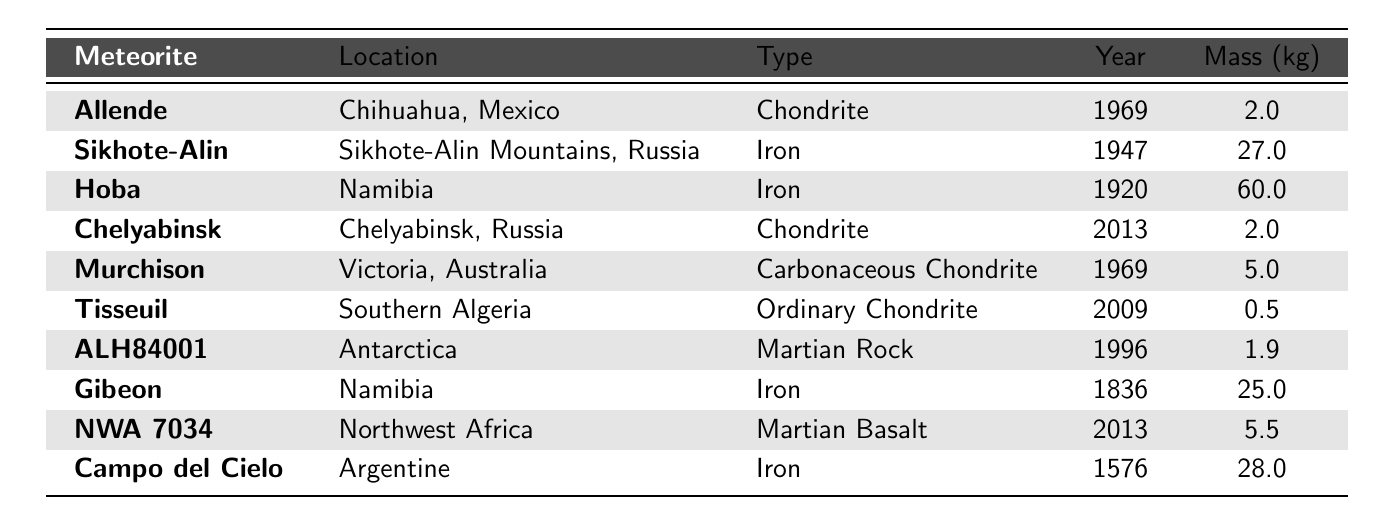What is the total mass of all exhibited meteorites? To find the total mass, we sum the masses listed in the table: 2.0 + 27.0 + 60.0 + 2.0 + 5.0 + 0.5 + 1.9 + 25.0 + 5.5 + 28.0 = 157.9 kg.
Answer: 157.9 kg Which meteorite was exhibited in the earliest year? Looking at the "Year" column, we see that "Campo del Cielo" was exhibited in 1576, which is the earliest year in the table.
Answer: Campo del Cielo How many iron meteorites are exhibited? By counting the entries in the "Type" column, we find that there are three iron meteorites: "Sikhote-Alin," "Hoba," and "Gibeon."
Answer: 4 What is the average mass of all exhibited meteorites? To calculate the average mass, we sum the masses (157.9 kg as discovered previously) and divide by the number of meteorites (10): 157.9 / 10 = 15.79 kg.
Answer: 15.79 kg Are there any meteorites that weigh less than 1 kg? Checking the "Mass" column, we find that "Tisseuil" has a mass of 0.5 kg, which is less than 1 kg.
Answer: Yes Which location has the largest meteorite by mass, and what is its mass? The meteorite "Hoba," located in Namibia, has the largest mass of 60.0 kg according to the "Mass" column.
Answer: Hoba, 60.0 kg How many meteorites were exhibited after the year 2000? From the "Year" column, we see that "Tisseuil," "ALH84001," "NWA 7034," and "Chelyabinsk" were exhibited after 2000. This gives us a total of 4 meteorites.
Answer: 4 Is there any meteorite from Antarctica? The table lists "ALH84001" and indicates that it is located in Antarctica.
Answer: Yes Which type of meteorite has the highest average mass? The average mass for each type is calculated: Iron (28.3 kg), Chondrite (2.0 kg), Carbonaceous Chondrite (5.0 kg), Ordinary Chondrite (0.5 kg), Martian Rock (1.9 kg), Martian Basalt (5.5 kg). Iron has the highest average mass of 28.3 kg.
Answer: Iron How many meteorites exhibited are chondrites? Reviewing the "Type" column, we find that "Allende," "Chelyabinsk," and "Murchison" are chondrites. Therefore, there are 3 chondrites exhibited.
Answer: 3 